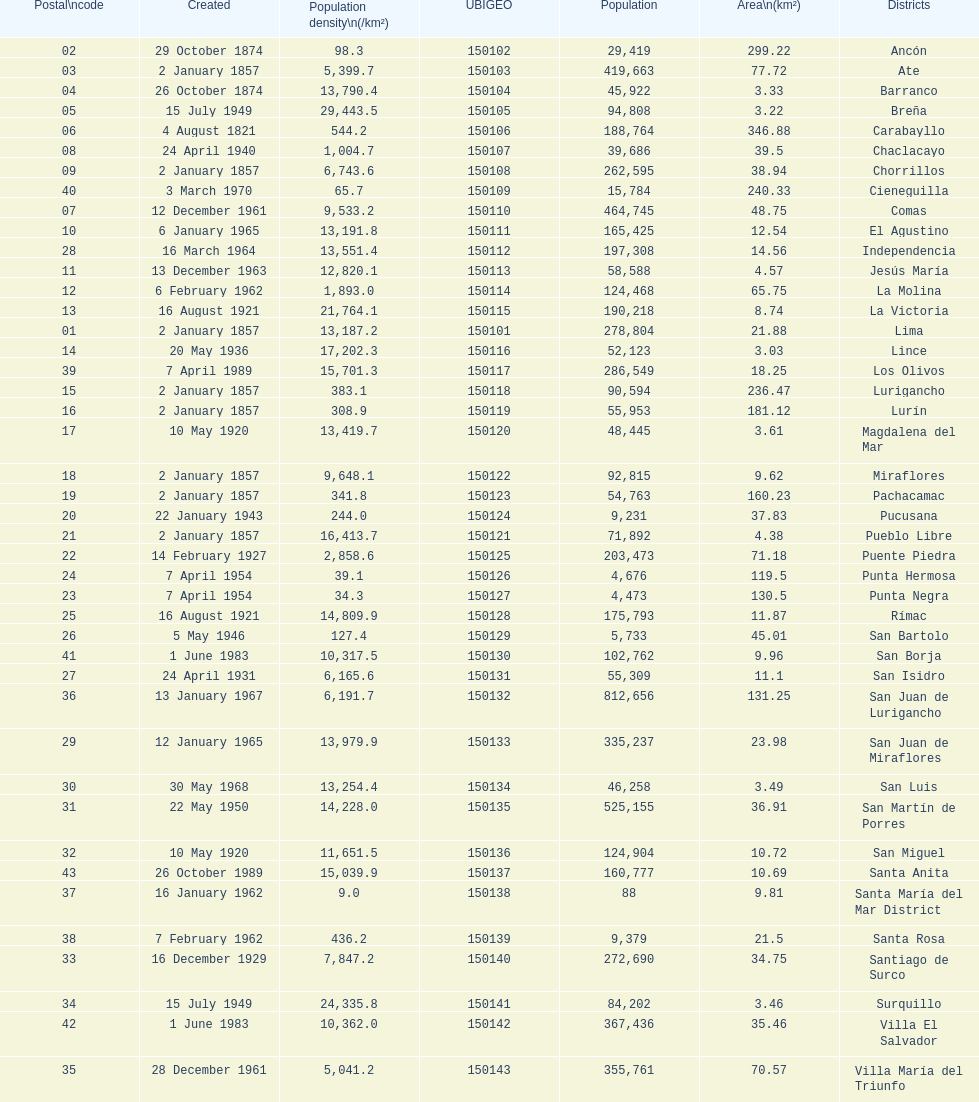What is the total number of districts of lima? 43. 